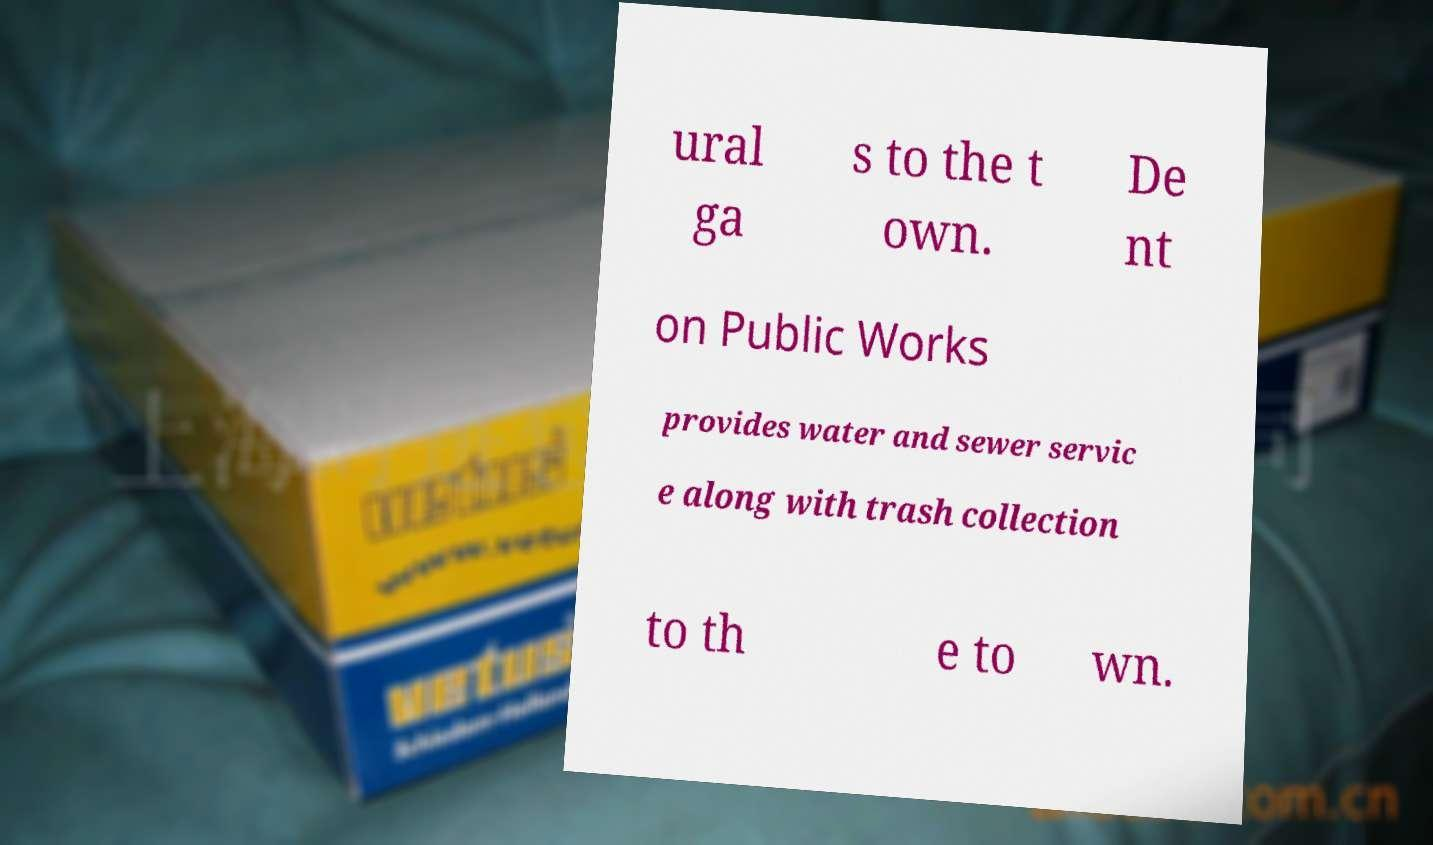Please identify and transcribe the text found in this image. ural ga s to the t own. De nt on Public Works provides water and sewer servic e along with trash collection to th e to wn. 